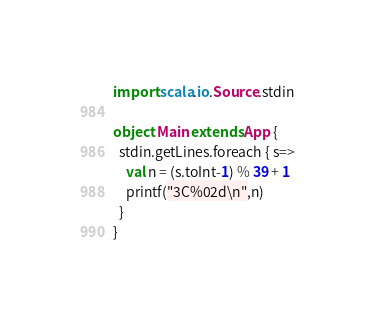<code> <loc_0><loc_0><loc_500><loc_500><_Scala_>import scala.io.Source.stdin

object Main extends App {
  stdin.getLines.foreach { s=>
    val n = (s.toInt-1) % 39 + 1
    printf("3C%02d\n",n)
  }
}</code> 